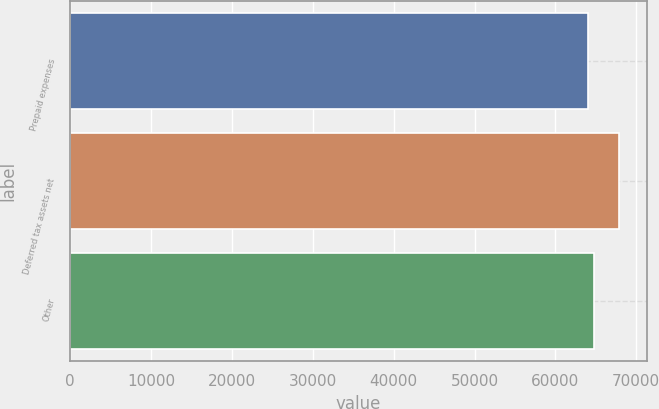<chart> <loc_0><loc_0><loc_500><loc_500><bar_chart><fcel>Prepaid expenses<fcel>Deferred tax assets net<fcel>Other<nl><fcel>64003<fcel>67879<fcel>64822<nl></chart> 